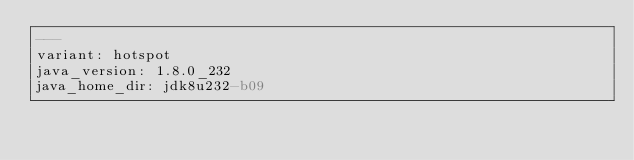<code> <loc_0><loc_0><loc_500><loc_500><_YAML_>---
variant: hotspot
java_version: 1.8.0_232
java_home_dir: jdk8u232-b09
</code> 